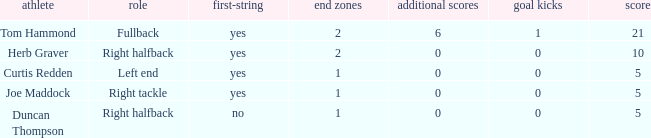Which player is assigned as the starter for the left end role? Yes. 